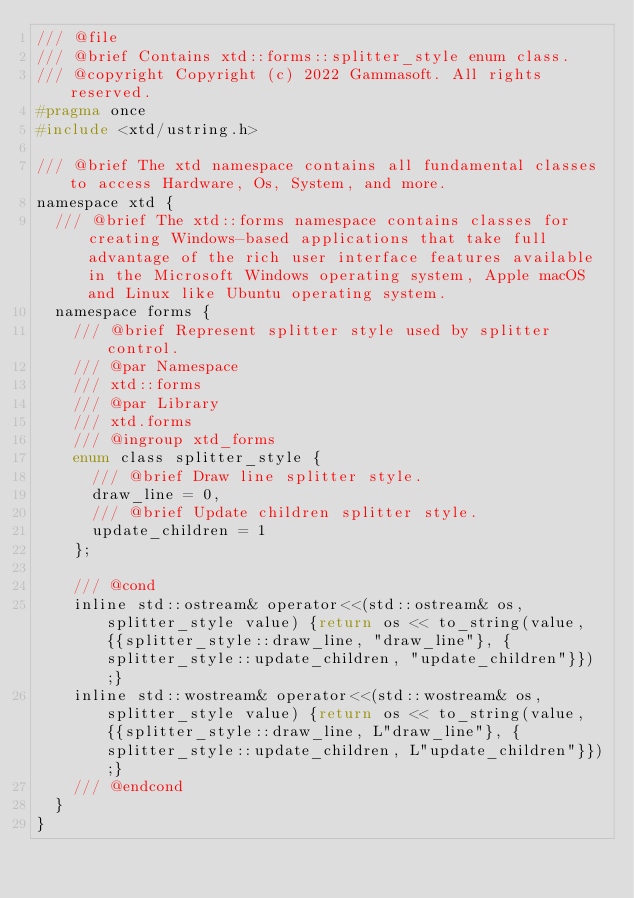Convert code to text. <code><loc_0><loc_0><loc_500><loc_500><_C_>/// @file
/// @brief Contains xtd::forms::splitter_style enum class.
/// @copyright Copyright (c) 2022 Gammasoft. All rights reserved.
#pragma once
#include <xtd/ustring.h>

/// @brief The xtd namespace contains all fundamental classes to access Hardware, Os, System, and more.
namespace xtd {
  /// @brief The xtd::forms namespace contains classes for creating Windows-based applications that take full advantage of the rich user interface features available in the Microsoft Windows operating system, Apple macOS and Linux like Ubuntu operating system.
  namespace forms {
    /// @brief Represent splitter style used by splitter control.
    /// @par Namespace
    /// xtd::forms
    /// @par Library
    /// xtd.forms
    /// @ingroup xtd_forms
    enum class splitter_style {
      /// @brief Draw line splitter style.
      draw_line = 0,
      /// @brief Update children splitter style.
      update_children = 1
    };
    
    /// @cond
    inline std::ostream& operator<<(std::ostream& os, splitter_style value) {return os << to_string(value, {{splitter_style::draw_line, "draw_line"}, {splitter_style::update_children, "update_children"}});}
    inline std::wostream& operator<<(std::wostream& os, splitter_style value) {return os << to_string(value, {{splitter_style::draw_line, L"draw_line"}, {splitter_style::update_children, L"update_children"}});}
    /// @endcond
  }
}
</code> 